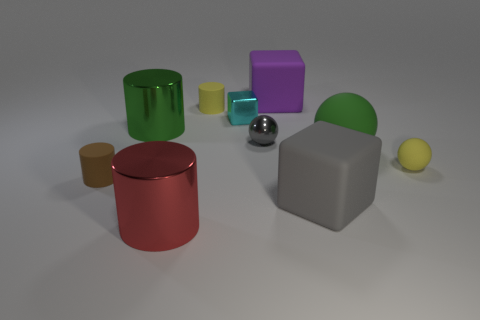Is the size of the rubber block behind the yellow cylinder the same as the green object that is to the right of the purple matte object? After examining the image closely, it appears that the rubber block behind the yellow cylinder and the green object beside the purple matte item are not exactly the same size. The rubber block is slightly larger in comparison, which demonstrates the subtle size variations between objects that can sometimes be challenging to discern at a glance. 